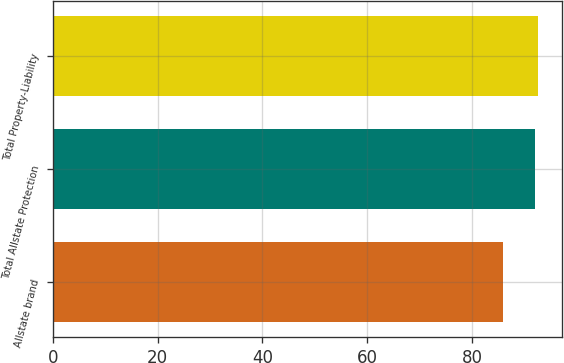Convert chart. <chart><loc_0><loc_0><loc_500><loc_500><bar_chart><fcel>Allstate brand<fcel>Total Allstate Protection<fcel>Total Property-Liability<nl><fcel>86<fcel>92<fcel>92.6<nl></chart> 